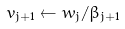Convert formula to latex. <formula><loc_0><loc_0><loc_500><loc_500>v _ { j + 1 } \leftarrow w _ { j } / \beta _ { j + 1 }</formula> 